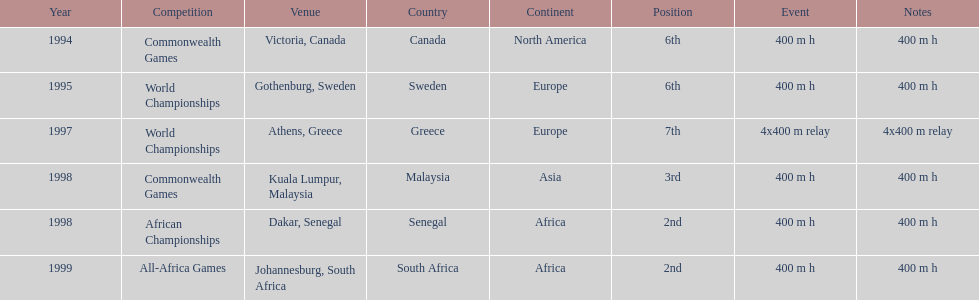Parse the table in full. {'header': ['Year', 'Competition', 'Venue', 'Country', 'Continent', 'Position', 'Event', 'Notes'], 'rows': [['1994', 'Commonwealth Games', 'Victoria, Canada', 'Canada', 'North America', '6th', '400 m h', '400 m h'], ['1995', 'World Championships', 'Gothenburg, Sweden', 'Sweden', 'Europe', '6th', '400 m h', '400 m h'], ['1997', 'World Championships', 'Athens, Greece', 'Greece', 'Europe', '7th', '4x400 m relay', '4x400 m relay'], ['1998', 'Commonwealth Games', 'Kuala Lumpur, Malaysia', 'Malaysia', 'Asia', '3rd', '400 m h', '400 m h'], ['1998', 'African Championships', 'Dakar, Senegal', 'Senegal', 'Africa', '2nd', '400 m h', '400 m h'], ['1999', 'All-Africa Games', 'Johannesburg, South Africa', 'South Africa', 'Africa', '2nd', '400 m h', '400 m h']]} How long was the relay at the 1997 world championships that ken harden ran 4x400 m relay. 